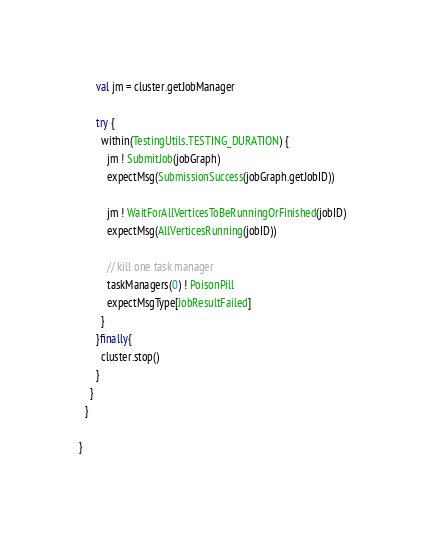<code> <loc_0><loc_0><loc_500><loc_500><_Scala_>      val jm = cluster.getJobManager

      try {
        within(TestingUtils.TESTING_DURATION) {
          jm ! SubmitJob(jobGraph)
          expectMsg(SubmissionSuccess(jobGraph.getJobID))

          jm ! WaitForAllVerticesToBeRunningOrFinished(jobID)
          expectMsg(AllVerticesRunning(jobID))

          // kill one task manager
          taskManagers(0) ! PoisonPill
          expectMsgType[JobResultFailed]
        }
      }finally{
        cluster.stop()
      }
    }
  }

}
</code> 